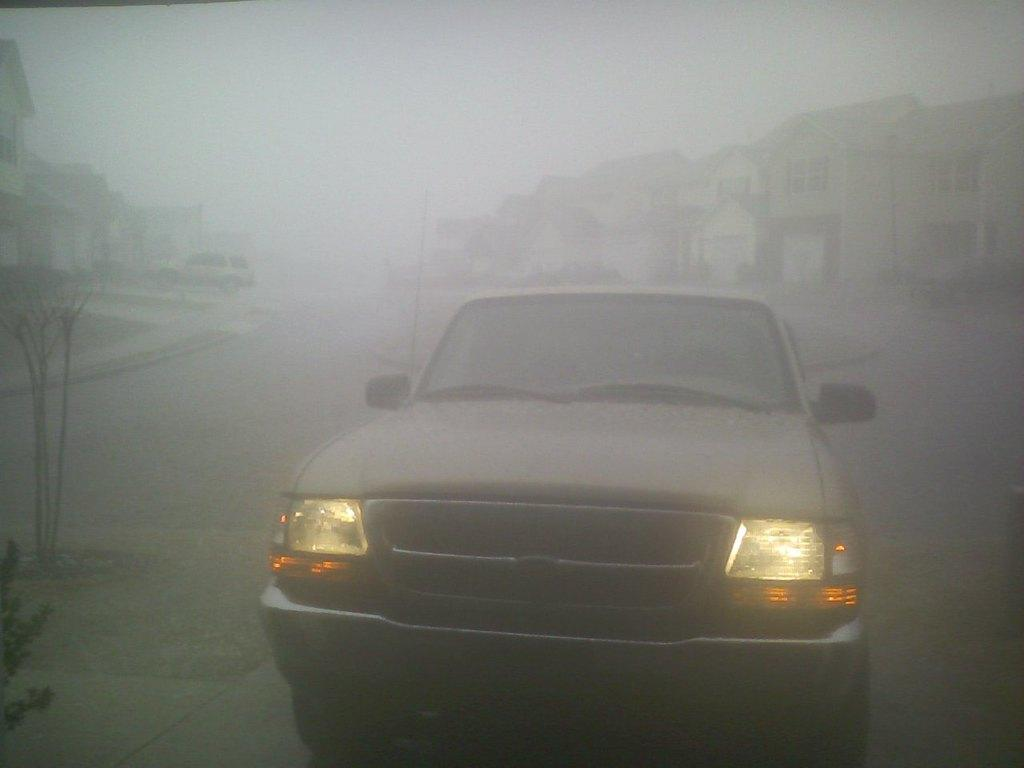What is the main subject of the image? There is a car on the road in the image. Can you describe any other vehicles in the image? Yes, there is a vehicle in the background of the image. What can be seen in the background of the image besides the vehicle? There are buildings and the sky visible in the background of the image. What type of wound does the daughter have in the image? There is no daughter or wound present in the image. 